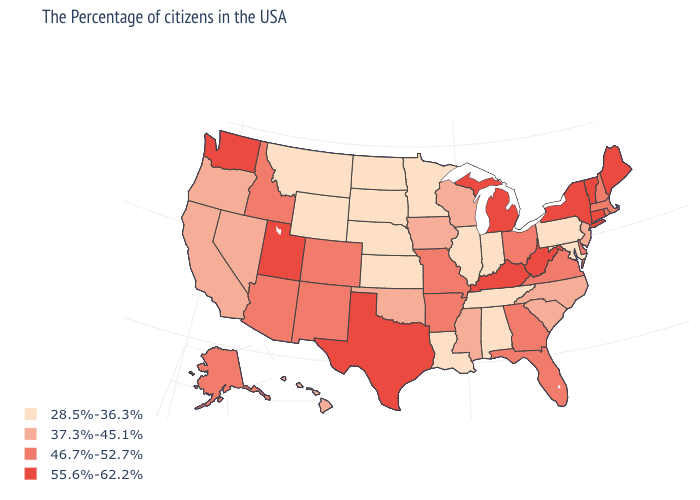Name the states that have a value in the range 55.6%-62.2%?
Be succinct. Maine, Vermont, Connecticut, New York, West Virginia, Michigan, Kentucky, Texas, Utah, Washington. Among the states that border Massachusetts , which have the lowest value?
Quick response, please. Rhode Island, New Hampshire. Does North Carolina have the lowest value in the USA?
Quick response, please. No. Which states have the lowest value in the USA?
Keep it brief. Maryland, Pennsylvania, Indiana, Alabama, Tennessee, Illinois, Louisiana, Minnesota, Kansas, Nebraska, South Dakota, North Dakota, Wyoming, Montana. Does Kentucky have the lowest value in the South?
Write a very short answer. No. What is the value of Colorado?
Concise answer only. 46.7%-52.7%. What is the highest value in the USA?
Concise answer only. 55.6%-62.2%. Does Oklahoma have a higher value than Minnesota?
Short answer required. Yes. Among the states that border Michigan , which have the lowest value?
Give a very brief answer. Indiana. What is the value of Kansas?
Give a very brief answer. 28.5%-36.3%. What is the highest value in states that border New Jersey?
Write a very short answer. 55.6%-62.2%. Does South Dakota have the lowest value in the USA?
Answer briefly. Yes. Among the states that border New Jersey , which have the lowest value?
Keep it brief. Pennsylvania. Does Wisconsin have the lowest value in the MidWest?
Keep it brief. No. 